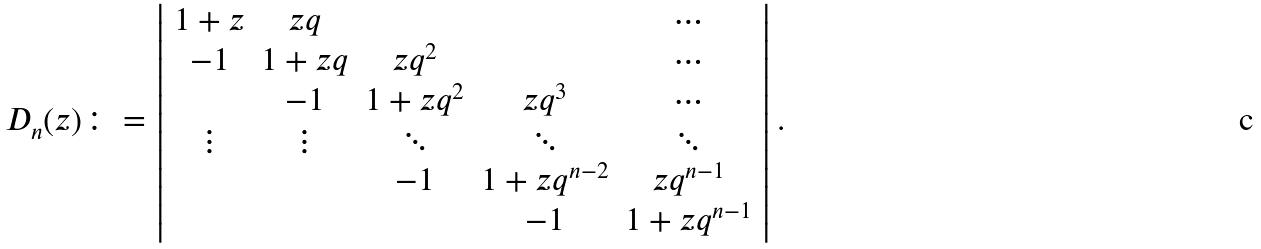Convert formula to latex. <formula><loc_0><loc_0><loc_500><loc_500>D _ { n } ( z ) \colon = \left | \begin{array} { c c c c c } 1 + z & z q & & & \cdots \\ - 1 & 1 + z q & z q ^ { 2 } & & \cdots \\ & - 1 & 1 + z q ^ { 2 } & z q ^ { 3 } & \cdots \\ \vdots & \vdots & \ddots & \ddots & \ddots \\ & & - 1 & 1 + z q ^ { n - 2 } & z q ^ { n - 1 } \\ & & & - 1 & 1 + z q ^ { n - 1 } \\ \end{array} \right | .</formula> 